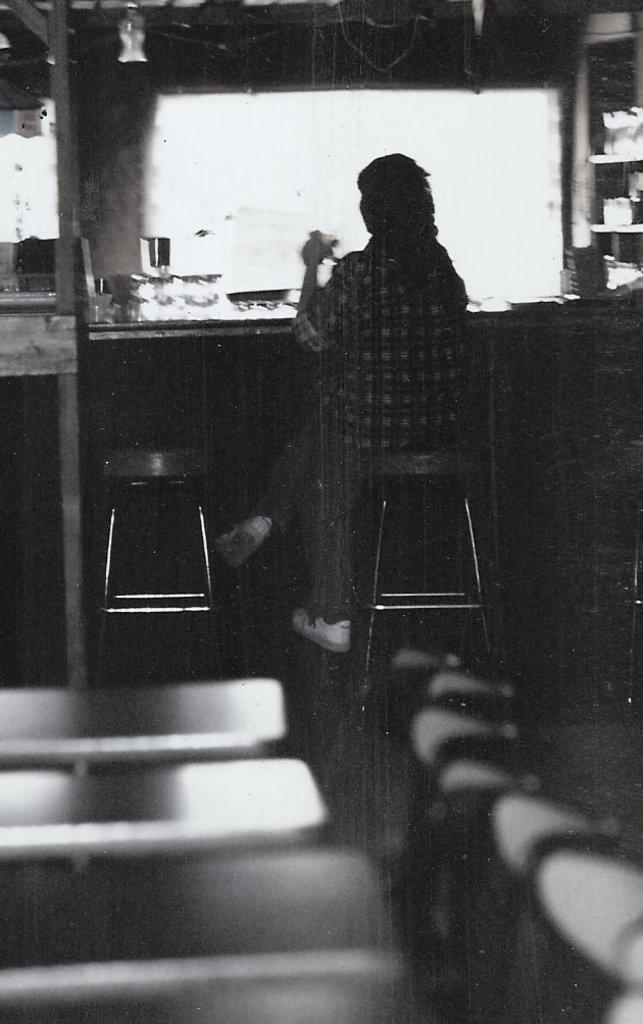What type of furniture is present in the image? There are tables and chairs in the image. What is the person in the image doing? The person is sitting on a chair. Are there any objects on the table in the image? Yes, there are objects on the table in front of the person. Can you see any smoke coming from the person's business in the image? There is no mention of smoke or a business in the image; it features tables, chairs, and a person sitting on a chair. What type of pancake is the person eating in the image? There is no pancake present in the image. 